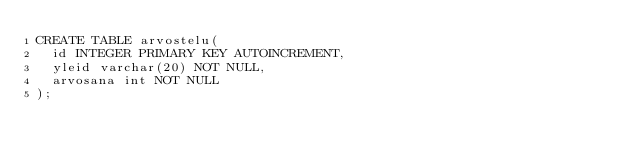<code> <loc_0><loc_0><loc_500><loc_500><_SQL_>CREATE TABLE arvostelu(
  id INTEGER PRIMARY KEY AUTOINCREMENT,
  yleid varchar(20) NOT NULL,
  arvosana int NOT NULL
);
</code> 